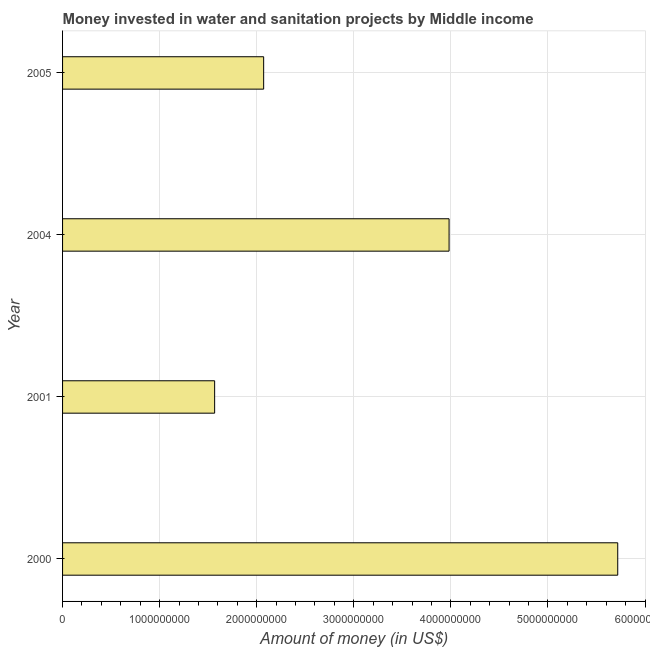Does the graph contain any zero values?
Provide a short and direct response. No. Does the graph contain grids?
Ensure brevity in your answer.  Yes. What is the title of the graph?
Make the answer very short. Money invested in water and sanitation projects by Middle income. What is the label or title of the X-axis?
Provide a succinct answer. Amount of money (in US$). What is the investment in 2001?
Provide a short and direct response. 1.57e+09. Across all years, what is the maximum investment?
Give a very brief answer. 5.72e+09. Across all years, what is the minimum investment?
Your answer should be compact. 1.57e+09. What is the sum of the investment?
Give a very brief answer. 1.33e+1. What is the difference between the investment in 2000 and 2005?
Provide a short and direct response. 3.65e+09. What is the average investment per year?
Make the answer very short. 3.33e+09. What is the median investment?
Provide a succinct answer. 3.03e+09. In how many years, is the investment greater than 1200000000 US$?
Give a very brief answer. 4. Do a majority of the years between 2000 and 2005 (inclusive) have investment greater than 4800000000 US$?
Your response must be concise. No. What is the ratio of the investment in 2000 to that in 2004?
Ensure brevity in your answer.  1.44. What is the difference between the highest and the second highest investment?
Keep it short and to the point. 1.74e+09. What is the difference between the highest and the lowest investment?
Make the answer very short. 4.15e+09. In how many years, is the investment greater than the average investment taken over all years?
Your answer should be very brief. 2. How many years are there in the graph?
Offer a terse response. 4. Are the values on the major ticks of X-axis written in scientific E-notation?
Offer a terse response. No. What is the Amount of money (in US$) in 2000?
Give a very brief answer. 5.72e+09. What is the Amount of money (in US$) of 2001?
Your answer should be compact. 1.57e+09. What is the Amount of money (in US$) in 2004?
Your answer should be very brief. 3.98e+09. What is the Amount of money (in US$) of 2005?
Provide a succinct answer. 2.07e+09. What is the difference between the Amount of money (in US$) in 2000 and 2001?
Keep it short and to the point. 4.15e+09. What is the difference between the Amount of money (in US$) in 2000 and 2004?
Your answer should be very brief. 1.74e+09. What is the difference between the Amount of money (in US$) in 2000 and 2005?
Offer a terse response. 3.65e+09. What is the difference between the Amount of money (in US$) in 2001 and 2004?
Offer a very short reply. -2.41e+09. What is the difference between the Amount of money (in US$) in 2001 and 2005?
Ensure brevity in your answer.  -5.05e+08. What is the difference between the Amount of money (in US$) in 2004 and 2005?
Ensure brevity in your answer.  1.91e+09. What is the ratio of the Amount of money (in US$) in 2000 to that in 2001?
Keep it short and to the point. 3.65. What is the ratio of the Amount of money (in US$) in 2000 to that in 2004?
Keep it short and to the point. 1.44. What is the ratio of the Amount of money (in US$) in 2000 to that in 2005?
Your answer should be very brief. 2.76. What is the ratio of the Amount of money (in US$) in 2001 to that in 2004?
Offer a terse response. 0.39. What is the ratio of the Amount of money (in US$) in 2001 to that in 2005?
Your answer should be compact. 0.76. What is the ratio of the Amount of money (in US$) in 2004 to that in 2005?
Your response must be concise. 1.92. 